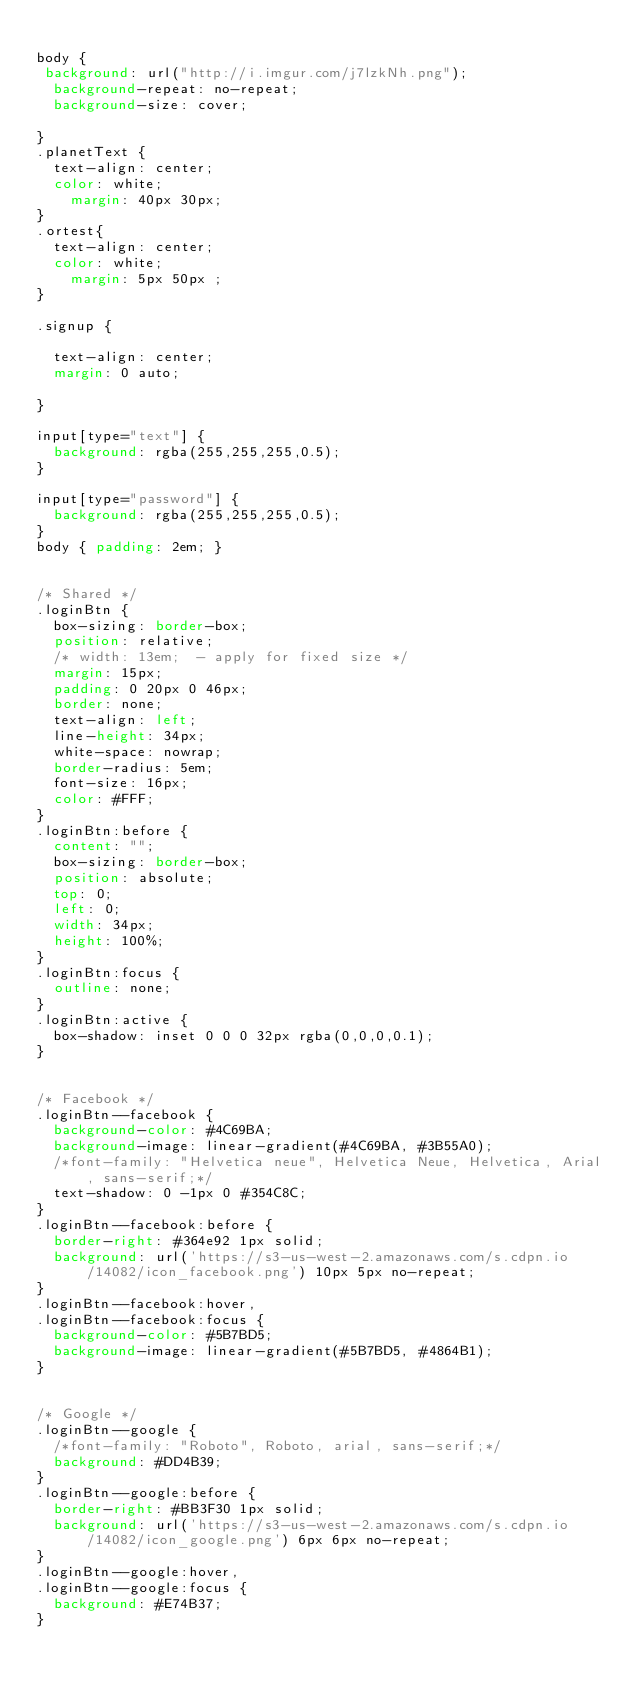Convert code to text. <code><loc_0><loc_0><loc_500><loc_500><_CSS_>
body {
 background: url("http://i.imgur.com/j7lzkNh.png");
  background-repeat: no-repeat;
  background-size: cover;
  
}
.planetText {
  text-align: center;
  color: white;
    margin: 40px 30px;
}
.ortest{
  text-align: center;
  color: white;
    margin: 5px 50px ; 
}

.signup {
  
  text-align: center;
  margin: 0 auto;
  
}

input[type="text"] {
  background: rgba(255,255,255,0.5);
}

input[type="password"] {
  background: rgba(255,255,255,0.5);
}
body { padding: 2em; }


/* Shared */
.loginBtn {
  box-sizing: border-box;
  position: relative;
  /* width: 13em;  - apply for fixed size */
  margin: 15px;
  padding: 0 20px 0 46px;
  border: none;
  text-align: left;
  line-height: 34px;
  white-space: nowrap;
  border-radius: 5em;
  font-size: 16px;
  color: #FFF;
}
.loginBtn:before {
  content: "";
  box-sizing: border-box;
  position: absolute;
  top: 0;
  left: 0;
  width: 34px;
  height: 100%;
}
.loginBtn:focus {
  outline: none;
}
.loginBtn:active {
  box-shadow: inset 0 0 0 32px rgba(0,0,0,0.1);
}


/* Facebook */
.loginBtn--facebook {
  background-color: #4C69BA;
  background-image: linear-gradient(#4C69BA, #3B55A0);
  /*font-family: "Helvetica neue", Helvetica Neue, Helvetica, Arial, sans-serif;*/
  text-shadow: 0 -1px 0 #354C8C;
}
.loginBtn--facebook:before {
  border-right: #364e92 1px solid;
  background: url('https://s3-us-west-2.amazonaws.com/s.cdpn.io/14082/icon_facebook.png') 10px 5px no-repeat;
}
.loginBtn--facebook:hover,
.loginBtn--facebook:focus {
  background-color: #5B7BD5;
  background-image: linear-gradient(#5B7BD5, #4864B1);
}


/* Google */
.loginBtn--google {
  /*font-family: "Roboto", Roboto, arial, sans-serif;*/
  background: #DD4B39;
}
.loginBtn--google:before {
  border-right: #BB3F30 1px solid;
  background: url('https://s3-us-west-2.amazonaws.com/s.cdpn.io/14082/icon_google.png') 6px 6px no-repeat;
}
.loginBtn--google:hover,
.loginBtn--google:focus {
  background: #E74B37;
}</code> 